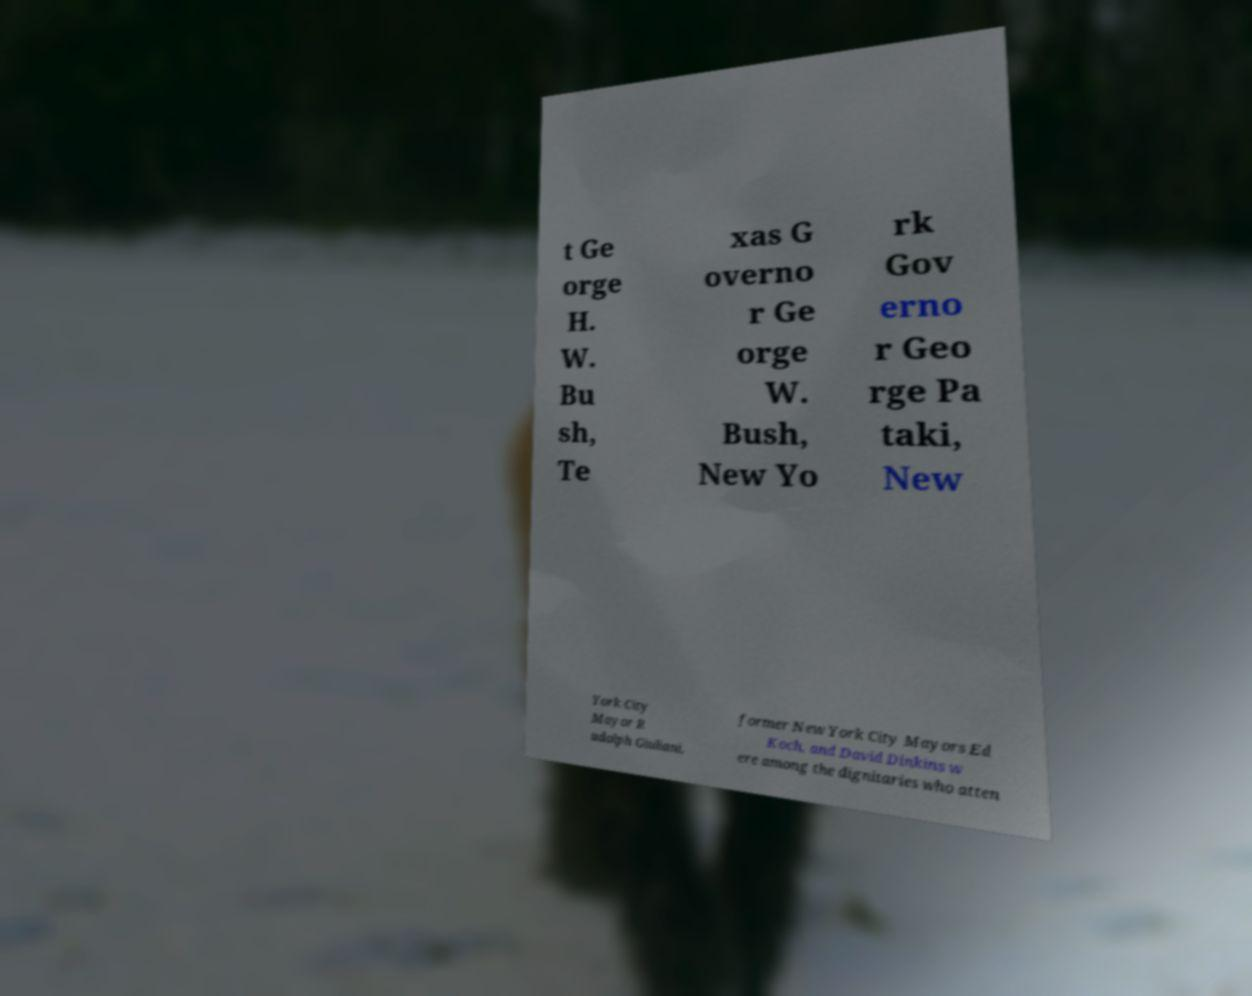Please identify and transcribe the text found in this image. t Ge orge H. W. Bu sh, Te xas G overno r Ge orge W. Bush, New Yo rk Gov erno r Geo rge Pa taki, New York City Mayor R udolph Giuliani, former New York City Mayors Ed Koch, and David Dinkins w ere among the dignitaries who atten 